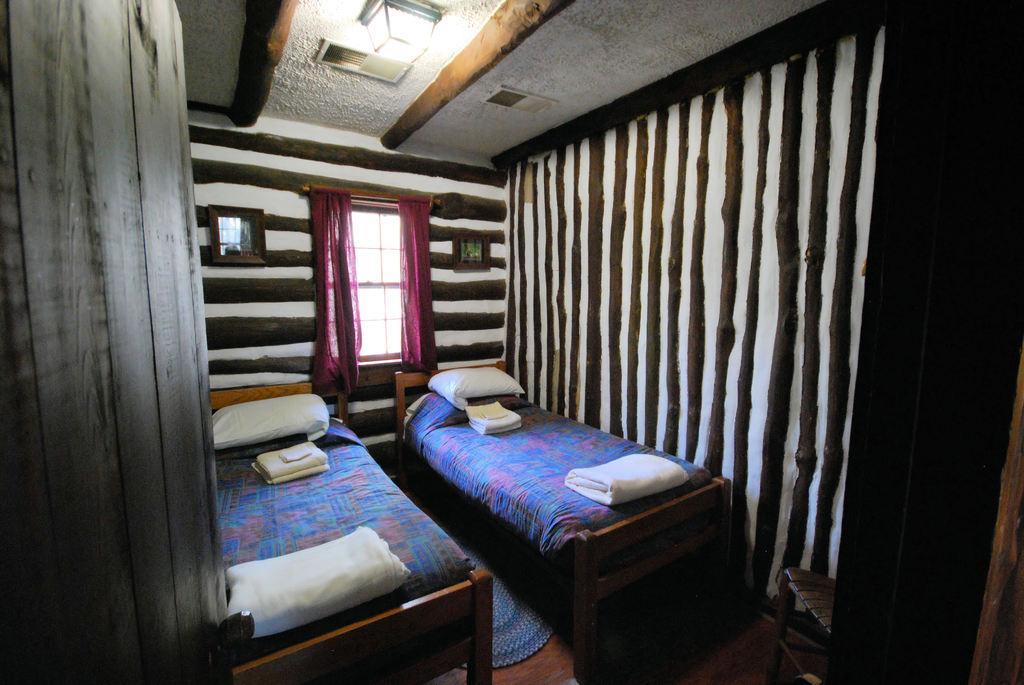In one or two sentences, can you explain what this image depicts? In this image I can see two beds and I can also see few pillow in white color, curtains in maroon color and the wall is in white and brown color and I can also see the light. 